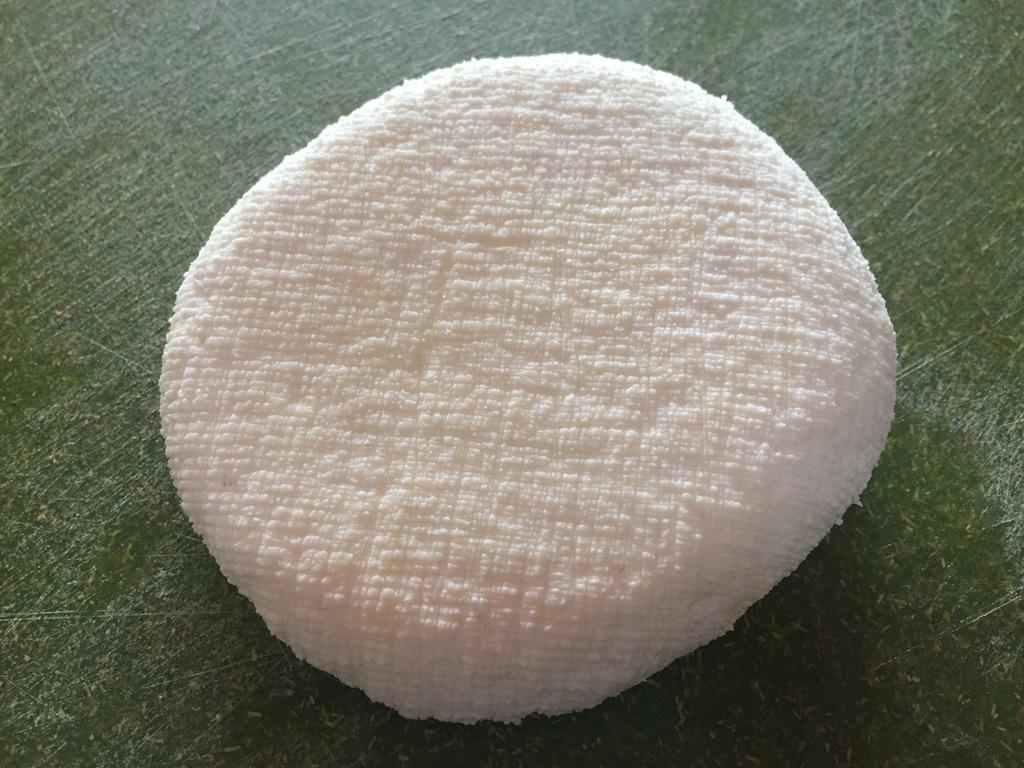How would you summarize this image in a sentence or two? In this picture there is a white color cloth on the table. 